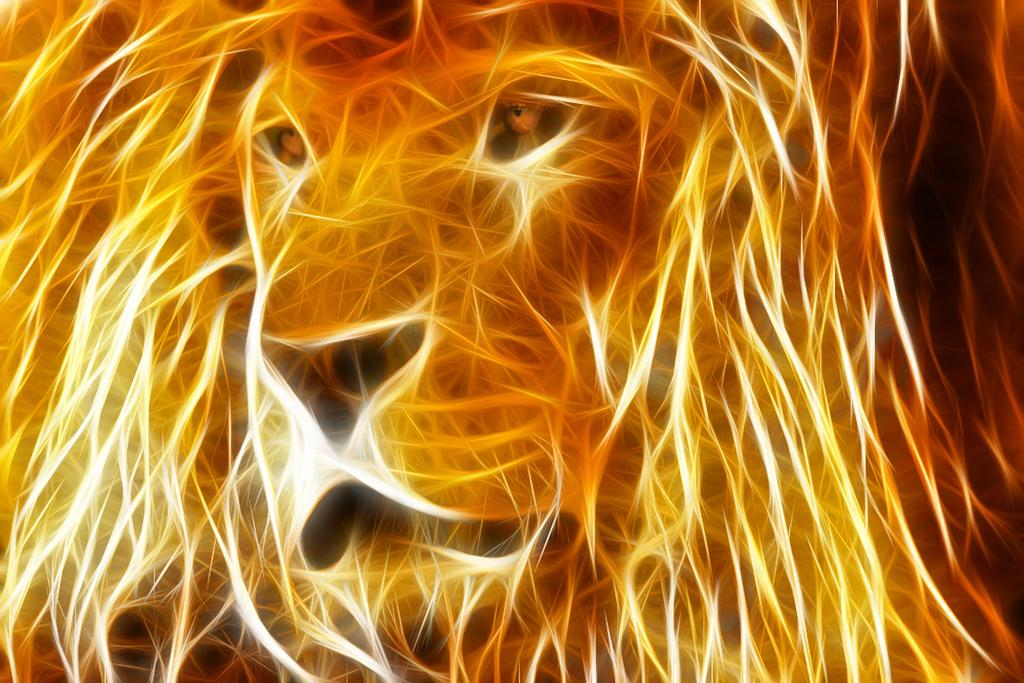What type of image is being described? The image is graphical in nature. What can be seen in the graphical image? The image contains the face of an animal. What type of celery is being used to treat the wound on the animal's face in the image? There is no celery or wound present in the image; it only contains the face of an animal. 